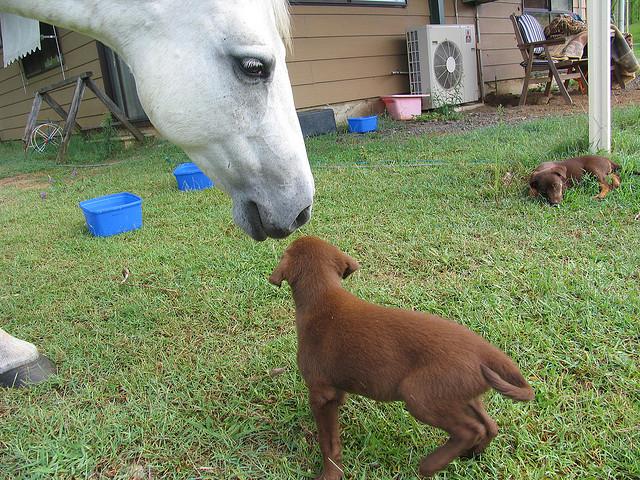What color is the house?
Quick response, please. Brown. Are the horse and the puppy friends?
Keep it brief. Yes. Are both dogs standing?
Write a very short answer. No. 